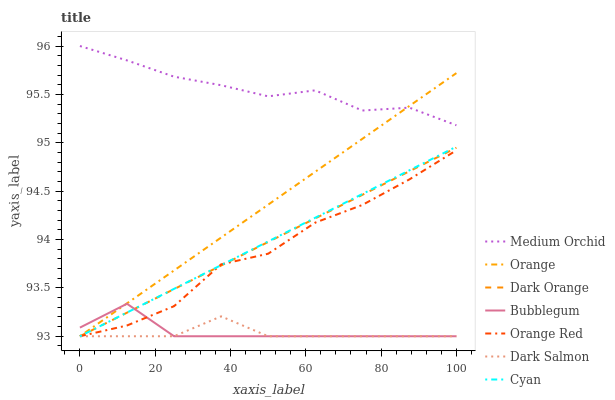Does Dark Salmon have the minimum area under the curve?
Answer yes or no. Yes. Does Medium Orchid have the maximum area under the curve?
Answer yes or no. Yes. Does Medium Orchid have the minimum area under the curve?
Answer yes or no. No. Does Dark Salmon have the maximum area under the curve?
Answer yes or no. No. Is Dark Orange the smoothest?
Answer yes or no. Yes. Is Orange Red the roughest?
Answer yes or no. Yes. Is Medium Orchid the smoothest?
Answer yes or no. No. Is Medium Orchid the roughest?
Answer yes or no. No. Does Dark Orange have the lowest value?
Answer yes or no. Yes. Does Medium Orchid have the lowest value?
Answer yes or no. No. Does Medium Orchid have the highest value?
Answer yes or no. Yes. Does Dark Salmon have the highest value?
Answer yes or no. No. Is Dark Orange less than Medium Orchid?
Answer yes or no. Yes. Is Medium Orchid greater than Dark Salmon?
Answer yes or no. Yes. Does Bubblegum intersect Orange Red?
Answer yes or no. Yes. Is Bubblegum less than Orange Red?
Answer yes or no. No. Is Bubblegum greater than Orange Red?
Answer yes or no. No. Does Dark Orange intersect Medium Orchid?
Answer yes or no. No. 